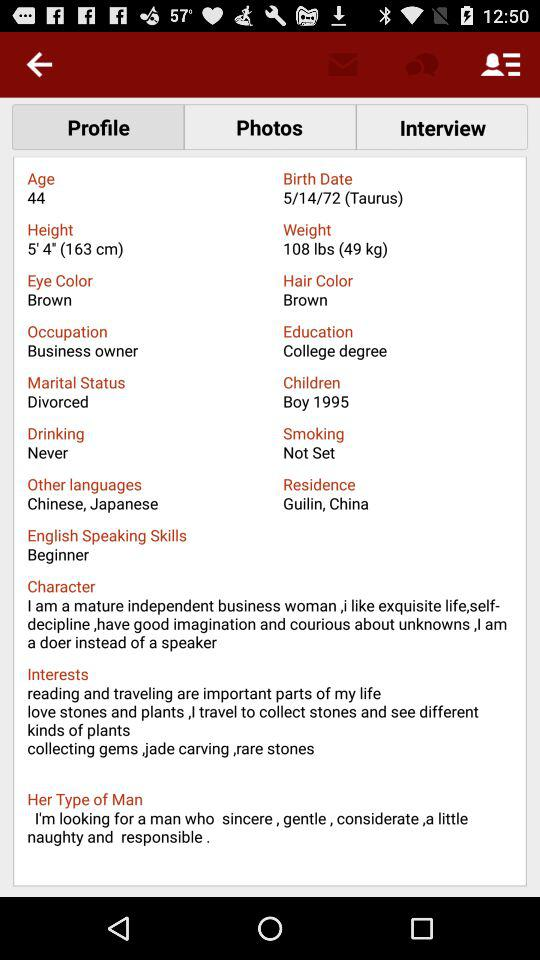What is the mentioned weight? The mentioned weight is 108 lbs (49 kg). 